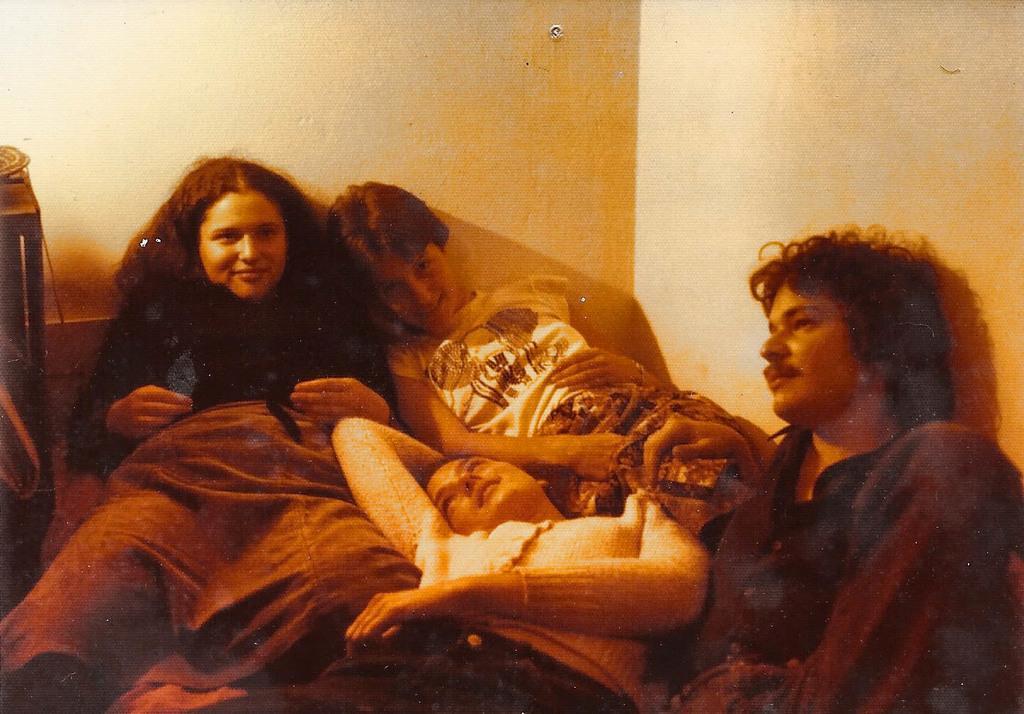Please provide a concise description of this image. In this image I see 4 persons in which these 3 of them are smiling and I see the wall and I can also see the shadows on the wall and I see a thing over here. 